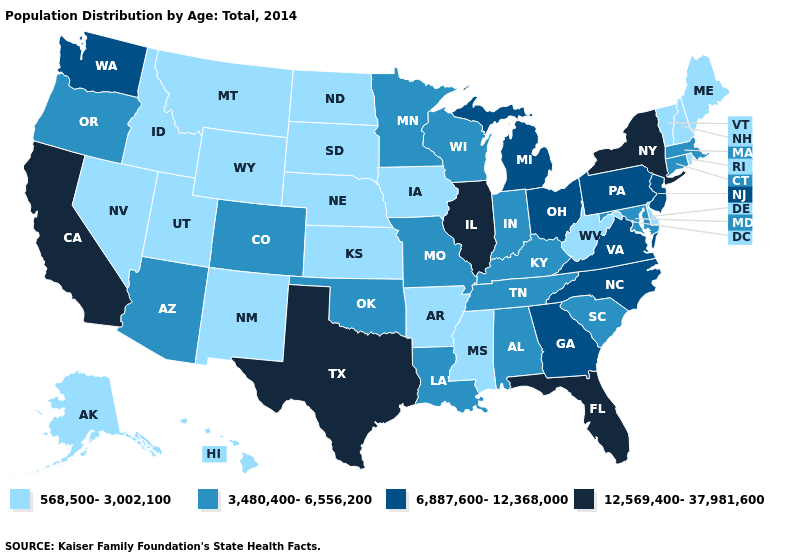Name the states that have a value in the range 568,500-3,002,100?
Be succinct. Alaska, Arkansas, Delaware, Hawaii, Idaho, Iowa, Kansas, Maine, Mississippi, Montana, Nebraska, Nevada, New Hampshire, New Mexico, North Dakota, Rhode Island, South Dakota, Utah, Vermont, West Virginia, Wyoming. Does Alaska have the lowest value in the West?
Write a very short answer. Yes. Name the states that have a value in the range 3,480,400-6,556,200?
Quick response, please. Alabama, Arizona, Colorado, Connecticut, Indiana, Kentucky, Louisiana, Maryland, Massachusetts, Minnesota, Missouri, Oklahoma, Oregon, South Carolina, Tennessee, Wisconsin. Does Montana have the lowest value in the USA?
Write a very short answer. Yes. Name the states that have a value in the range 6,887,600-12,368,000?
Answer briefly. Georgia, Michigan, New Jersey, North Carolina, Ohio, Pennsylvania, Virginia, Washington. Does Illinois have the highest value in the MidWest?
Answer briefly. Yes. Does Mississippi have the highest value in the USA?
Write a very short answer. No. Does Connecticut have the lowest value in the Northeast?
Concise answer only. No. Does West Virginia have a lower value than Oklahoma?
Concise answer only. Yes. Which states have the lowest value in the South?
Give a very brief answer. Arkansas, Delaware, Mississippi, West Virginia. What is the value of New Mexico?
Concise answer only. 568,500-3,002,100. Which states hav the highest value in the South?
Write a very short answer. Florida, Texas. Does West Virginia have a lower value than Indiana?
Keep it brief. Yes. Name the states that have a value in the range 12,569,400-37,981,600?
Short answer required. California, Florida, Illinois, New York, Texas. 